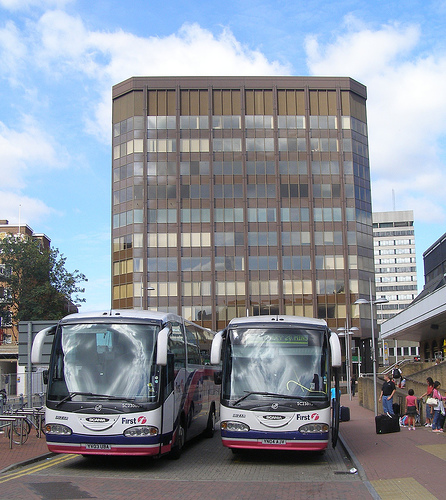Do you see a mirror to the left of the white bus? It's unclear if there are mirrors as part of the white bus. The bus design includes reflective surfaces that might be confusing as mirrors. 